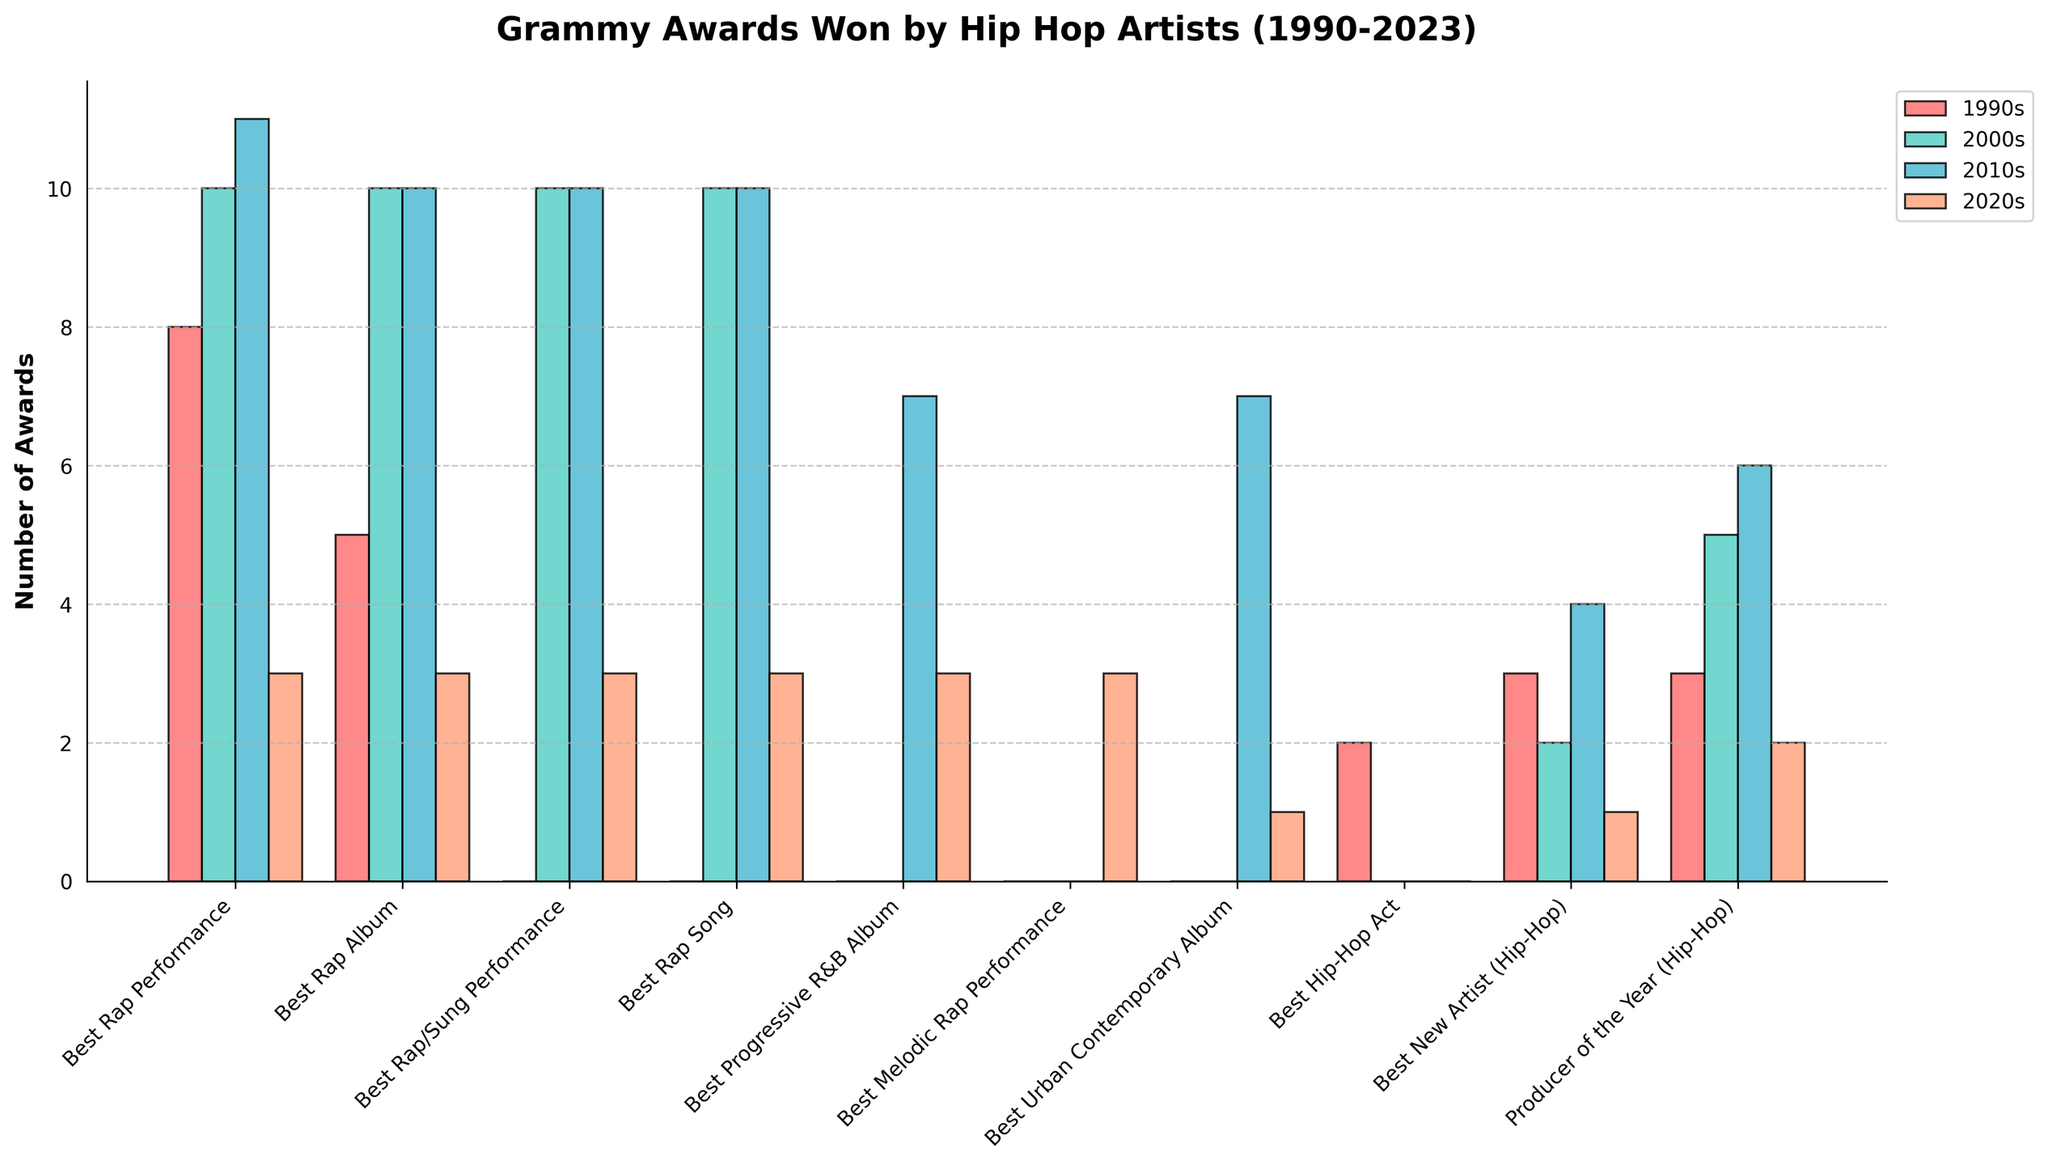Which category saw the highest number of awards in the 2000s? To find the answer, you need to look at the height of the bars for each category in the 2000s decade (colored in teal). The tallest bar indicates the category with the highest number of awards.
Answer: Best Rap Performance, Best Rap Album, Best Rap/Sung Performance, Best Rap Song (each with 10 awards) Which decade had the least awards for 'Producer of the Year (Hip-Hop)'? Compare the heights of the bars for 'Producer of the Year (Hip-Hop)' across all decades. The shortest bar represents the decade with the least number of awards.
Answer: 2020s How many total awards did hip-hop artists win in the 2010s across all categories? Sum up the heights of all the bars for the 2010s decade (colored in blue). Add the values for each category: 11 + 10 + 10 + 10 + 7 + 0 + 7 + 0 + 4 + 6.
Answer: 65 Which categories did not exist or had no winners in the 1990s? Check for categories where the height of the bar in the 1990s decade (colored in red) is zero. These include 'Best Rap/Sung Performance', 'Best Rap Song', 'Best Progressive R&B Album', 'Best Melodic Rap Performance', 'Best Urban Contemporary Album'.
Answer: Best Rap/Sung Performance, Best Rap Song, Best Progressive R&B Album, Best Melodic Rap Performance, Best Urban Contemporary Album In which decade did 'Best Urban Contemporary Album' receive the most awards? Compare the heights of the bars for 'Best Urban Contemporary Album' across all decades. The highest bar shows the decade with the most awards.
Answer: 2010s Which decade(s) had a tie for the most awards in 'Best Rap Album'? Check the heights of the bars for 'Best Rap Album' in each decade to identify any ties. Both the 2000s and 2010s have bars of equal height (10 awards).
Answer: 2000s, 2010s How many awards did 'Best Rap Song' win in the first decade it was introduced? Observe the first instance where the 'Best Rap Song' category has a non-zero height bar. It seems to start in the 2000s with 10 awards.
Answer: 10 Which categories consistently had winners across three decades? Look for categories where there are non-zero bars across three of the four decades. Categories such as 'Best Rap Album', 'Best Rap Performance', 'Best New Artist (Hip-Hop)', and 'Producer of the Year (Hip-Hop)' meet this criterion.
Answer: Best Rap Album, Best Rap Performance, Best New Artist (Hip-Hop), Producer of the Year (Hip-Hop) In which category and decade combination did hip-hop artists win exactly 3 awards? Identify the bars with a height of 3 and note the category and decade associated with those bars. The 'Best Rap Performance', 'Best Rap Album', 'Best Rap/Sung Performance', 'Best Rap Song', 'Best Progressive R&B Album', and 'Best Melodic Rap Performance' all won 3 awards in the 2020s. Additionally, 'Producer of the Year (Hip-Hop)' won 3 awards in the 1990s.
Answer: Best Rap Performance, Best Rap Album, Best Rap/Sung Performance, Best Rap Song, Best Progressive R&B Album, Best Melodic Rap Performance (2020s); Producer of the Year (Hip-Hop) (1990s) What is the total number of awards won by hip-hop artists in the 1990s and 2020s for 'Best New Artist (Hip-Hop)'? Sum the value for 'Best New Artist (Hip-Hop)' for the 1990s (3 awards) and 2020s (1 award). 3 + 1 = 4.
Answer: 4 